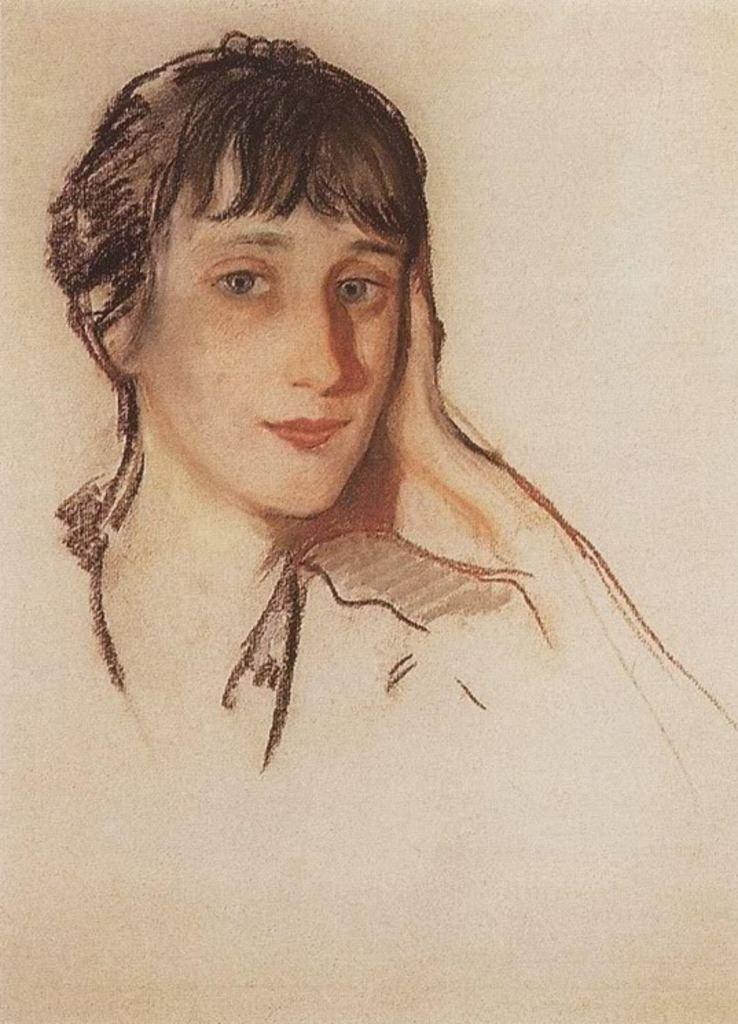What is the main subject of the image? There is an art piece in the image. What is depicted in the art piece? The art piece features a person. What color is the background of the art piece? The background of the art piece is cream-colored. How much money is being blown by the person in the art piece? There is no indication of money or blowing in the image; the art piece features a person with a cream-colored background. 